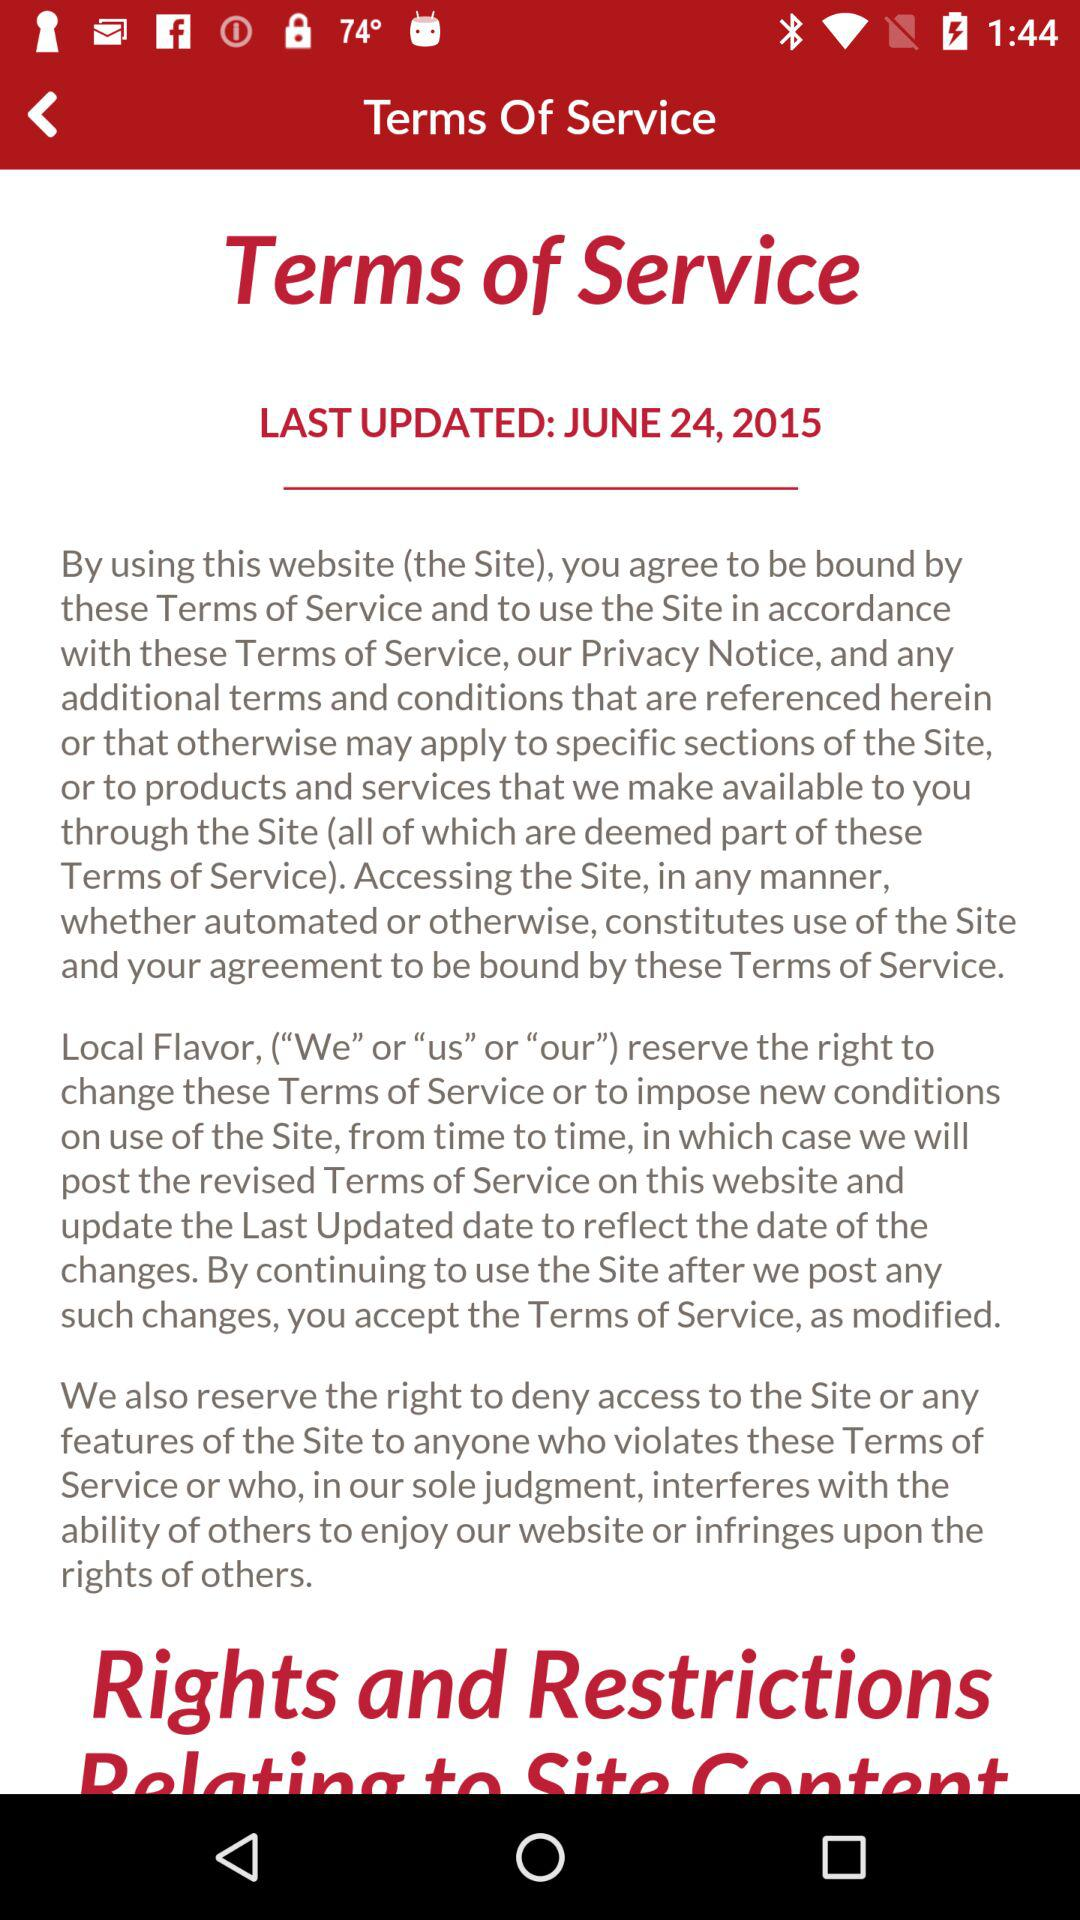What is the date of the last update? The date of the last update is June 24, 2015. 